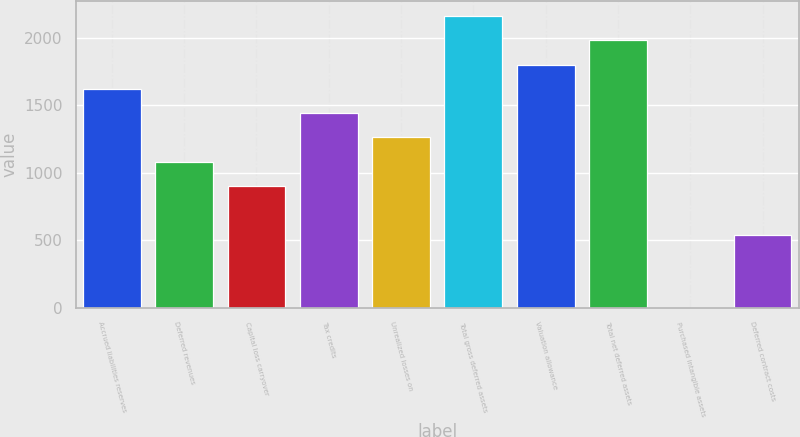Convert chart. <chart><loc_0><loc_0><loc_500><loc_500><bar_chart><fcel>Accrued liabilities reserves<fcel>Deferred revenues<fcel>Capital loss carryover<fcel>Tax credits<fcel>Unrealized losses on<fcel>Total gross deferred assets<fcel>Valuation allowance<fcel>Total net deferred assets<fcel>Purchased intangible assets<fcel>Deferred contract costs<nl><fcel>1622.9<fcel>1082.6<fcel>902.5<fcel>1442.8<fcel>1262.7<fcel>2163.2<fcel>1803<fcel>1983.1<fcel>2<fcel>542.3<nl></chart> 